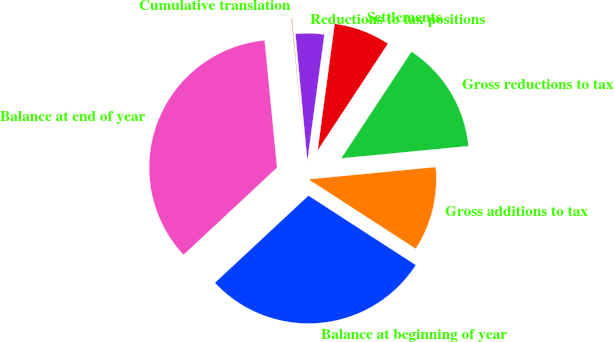Convert chart to OTSL. <chart><loc_0><loc_0><loc_500><loc_500><pie_chart><fcel>Balance at beginning of year<fcel>Gross additions to tax<fcel>Gross reductions to tax<fcel>Settlements<fcel>Reductions to tax positions<fcel>Cumulative translation<fcel>Balance at end of year<nl><fcel>28.92%<fcel>10.67%<fcel>14.2%<fcel>7.14%<fcel>3.61%<fcel>0.07%<fcel>35.39%<nl></chart> 